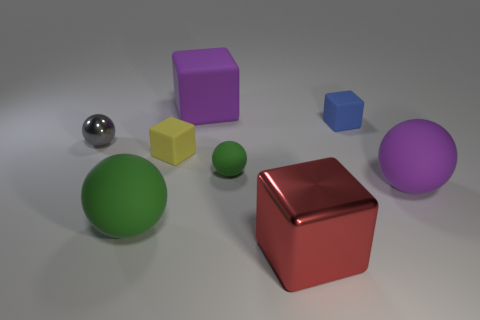There is a large rubber object behind the small gray ball; is it the same shape as the large purple matte thing that is right of the large metal cube?
Your response must be concise. No. Are there the same number of large red cubes that are to the left of the tiny yellow matte block and green things?
Keep it short and to the point. No. Is there any other thing that has the same size as the blue rubber cube?
Make the answer very short. Yes. There is another tiny object that is the same shape as the tiny metallic thing; what material is it?
Keep it short and to the point. Rubber. There is a purple rubber object that is right of the rubber cube to the right of the large metallic block; what is its shape?
Your response must be concise. Sphere. Do the small cube to the left of the small green thing and the tiny blue cube have the same material?
Keep it short and to the point. Yes. Are there an equal number of large purple objects that are in front of the large purple rubber cube and large green rubber spheres that are right of the red metal thing?
Make the answer very short. No. What material is the large ball that is the same color as the large rubber block?
Make the answer very short. Rubber. How many shiny things are behind the purple rubber object that is behind the blue rubber object?
Your answer should be compact. 0. There is a tiny cube to the right of the big red cube; does it have the same color as the large rubber object behind the yellow object?
Make the answer very short. No. 